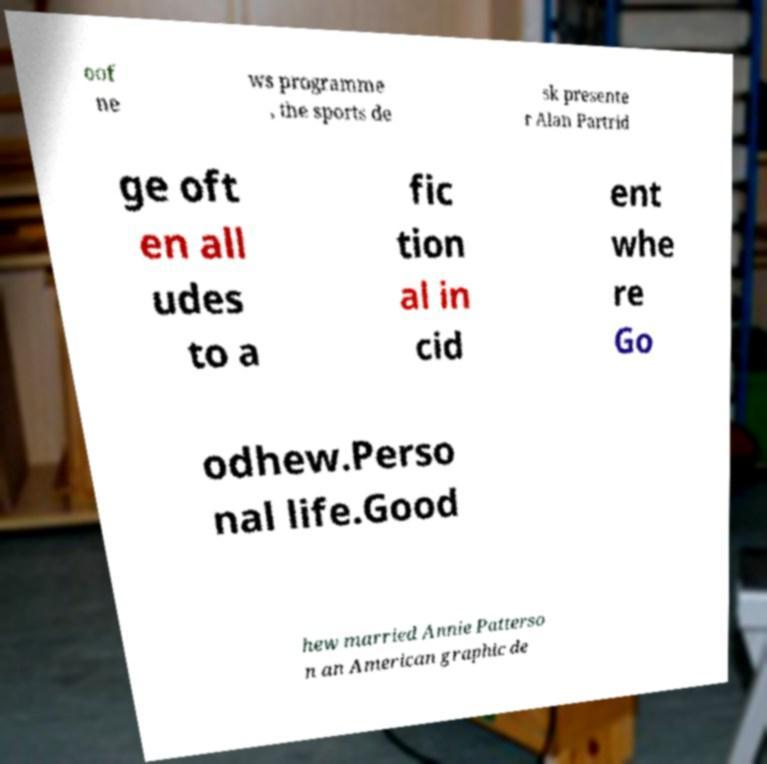There's text embedded in this image that I need extracted. Can you transcribe it verbatim? oof ne ws programme , the sports de sk presente r Alan Partrid ge oft en all udes to a fic tion al in cid ent whe re Go odhew.Perso nal life.Good hew married Annie Patterso n an American graphic de 